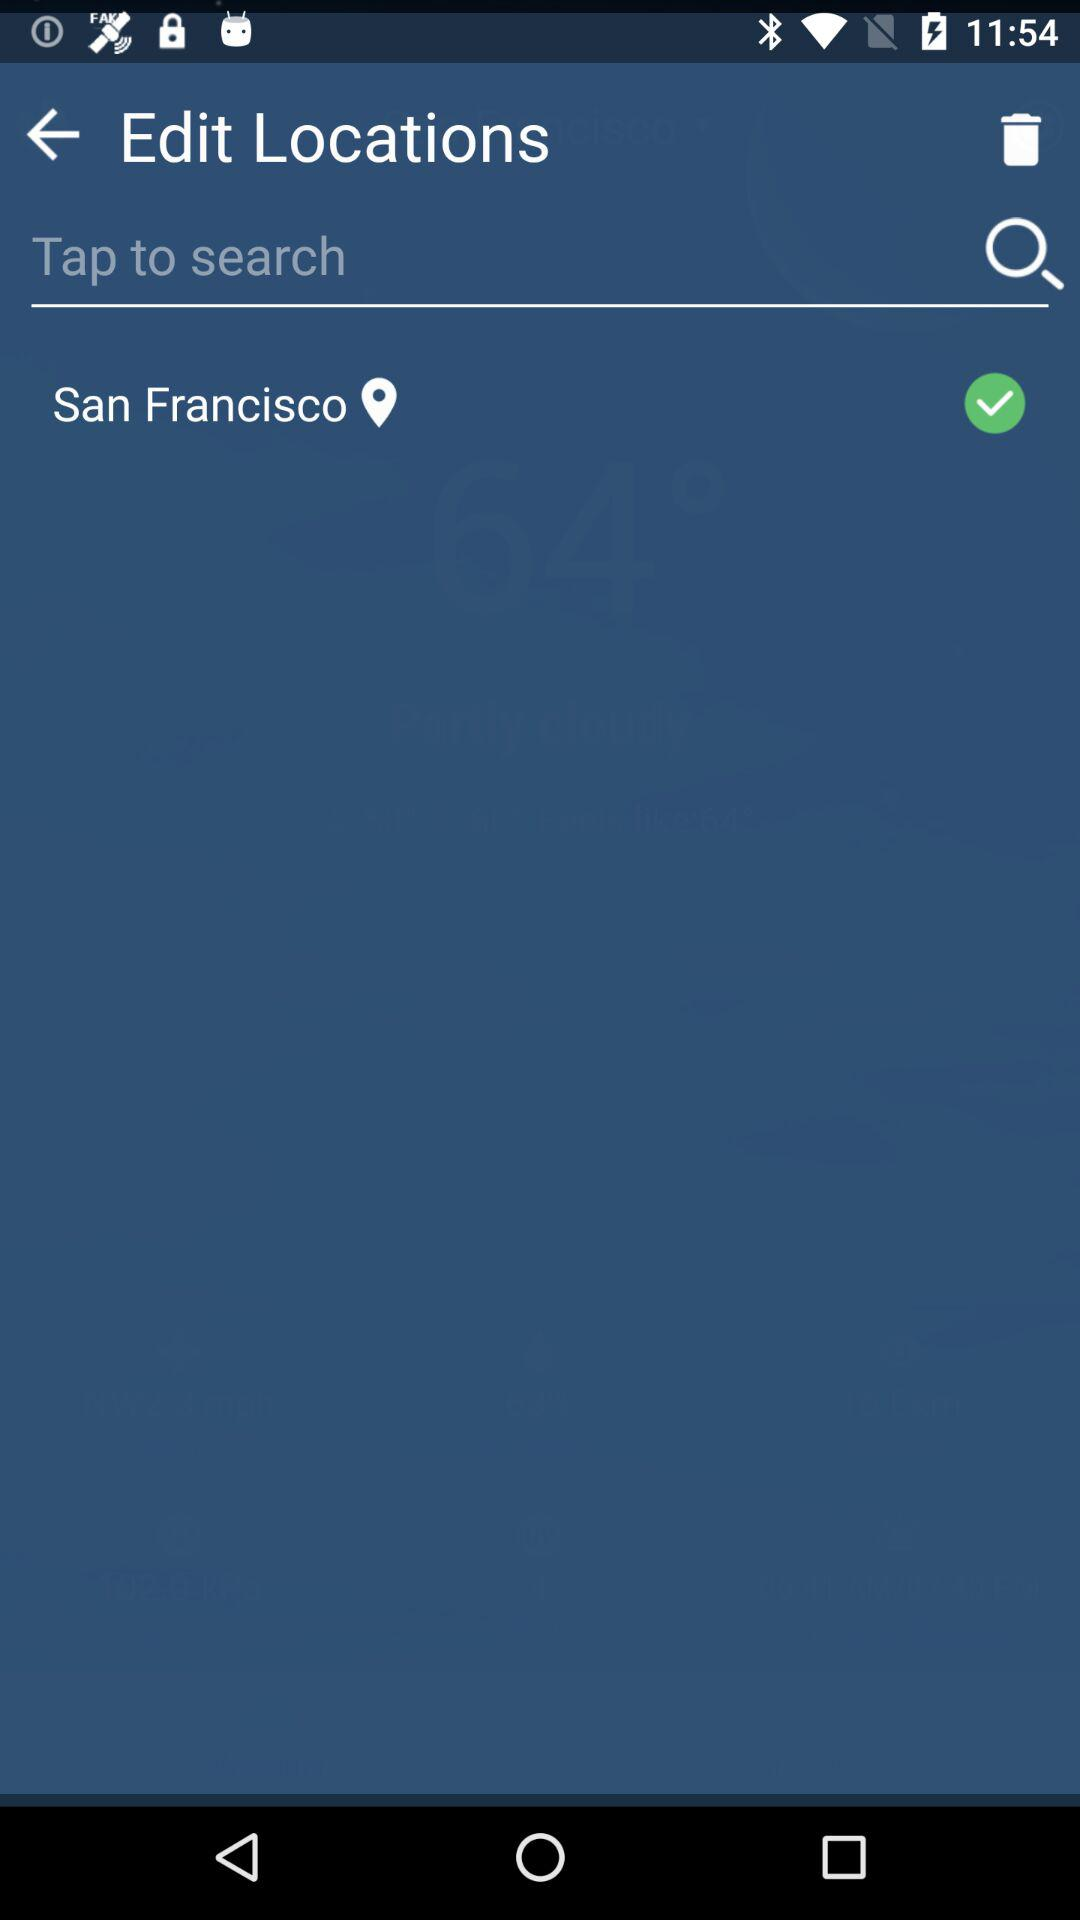What is the location? The location is San Francisco. 